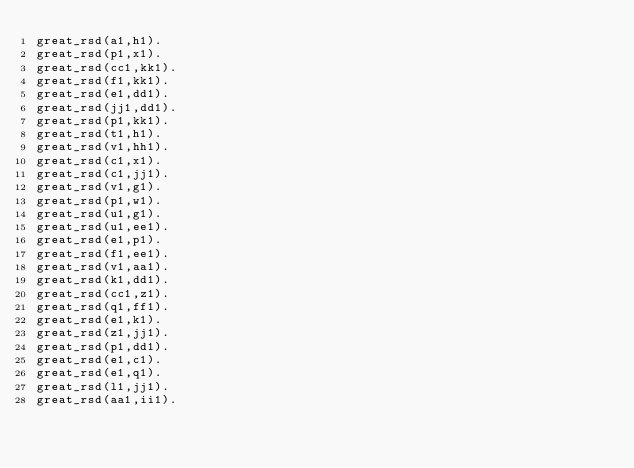<code> <loc_0><loc_0><loc_500><loc_500><_FORTRAN_>great_rsd(a1,h1).
great_rsd(p1,x1).
great_rsd(cc1,kk1).
great_rsd(f1,kk1).
great_rsd(e1,dd1).
great_rsd(jj1,dd1).
great_rsd(p1,kk1).
great_rsd(t1,h1).
great_rsd(v1,hh1).
great_rsd(c1,x1).
great_rsd(c1,jj1).
great_rsd(v1,g1).
great_rsd(p1,w1).
great_rsd(u1,g1).
great_rsd(u1,ee1).
great_rsd(e1,p1).
great_rsd(f1,ee1).
great_rsd(v1,aa1).
great_rsd(k1,dd1).
great_rsd(cc1,z1).
great_rsd(q1,ff1).
great_rsd(e1,k1).
great_rsd(z1,jj1).
great_rsd(p1,dd1).
great_rsd(e1,c1).
great_rsd(e1,q1).
great_rsd(l1,jj1).
great_rsd(aa1,ii1).
</code> 